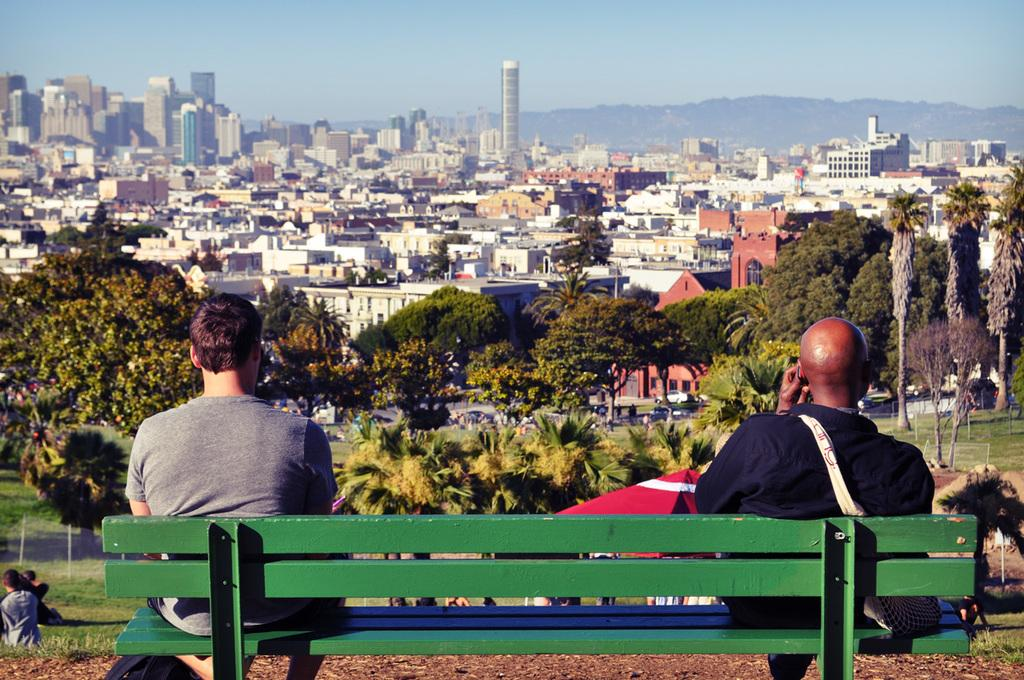How many people are sitting on the bench in the image? There are two people sitting on the bench in the image. What is in front of the bench? There are trees and many buildings in front of the bench. What type of pin can be seen on the tree in the image? There is no pin present on the tree in the image. What kind of flower is growing on the bench in the image? There are no flowers growing on the bench in the image. 